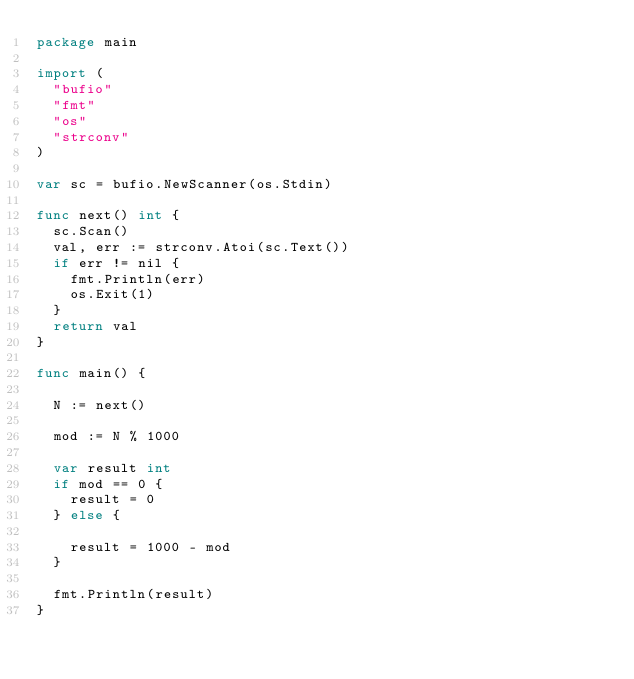Convert code to text. <code><loc_0><loc_0><loc_500><loc_500><_Go_>package main

import (
	"bufio"
	"fmt"
	"os"
	"strconv"
)

var sc = bufio.NewScanner(os.Stdin)

func next() int {
	sc.Scan()
	val, err := strconv.Atoi(sc.Text())
	if err != nil {
		fmt.Println(err)
		os.Exit(1)
	}
	return val
}

func main() {

	N := next()

	mod := N % 1000

	var result int
	if mod == 0 {
		result = 0
	} else {

		result = 1000 - mod
	}

	fmt.Println(result)
}</code> 